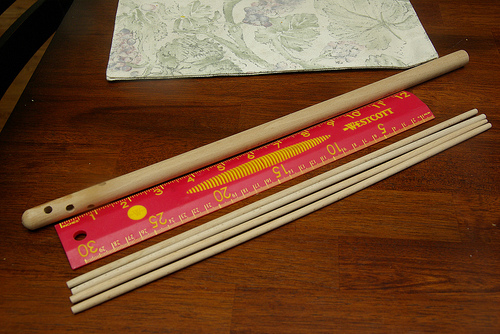<image>
Is there a grain behind the dowel? No. The grain is not behind the dowel. From this viewpoint, the grain appears to be positioned elsewhere in the scene. Where is the ruler in relation to the paper? Is it in front of the paper? Yes. The ruler is positioned in front of the paper, appearing closer to the camera viewpoint. 